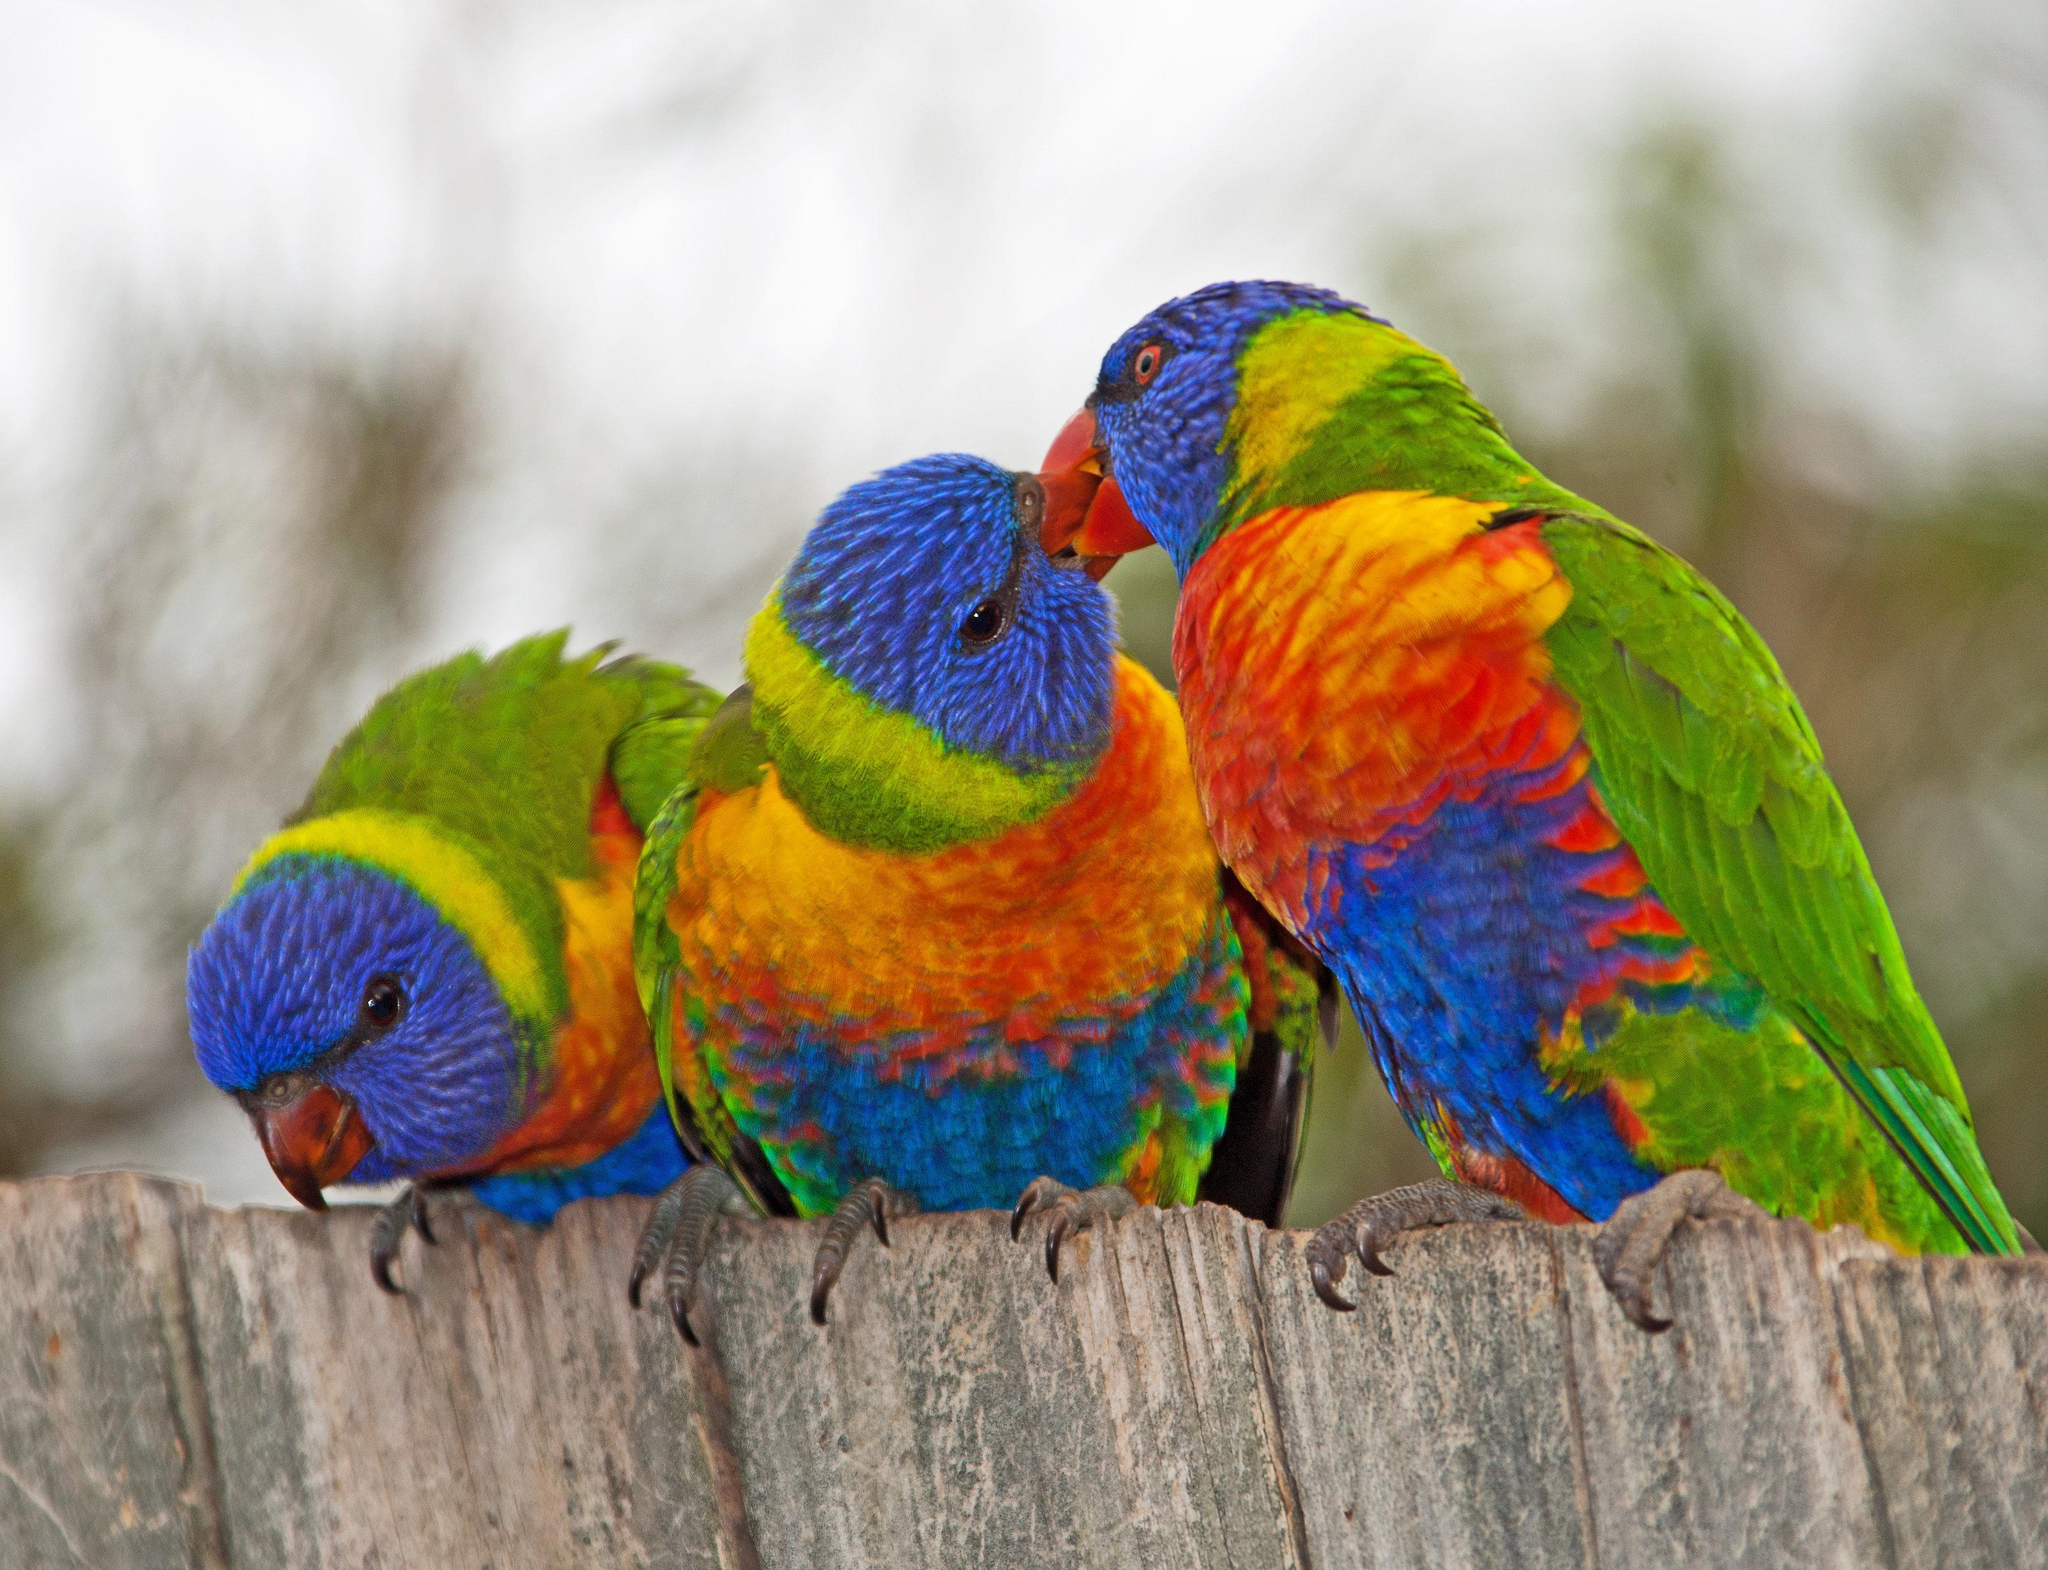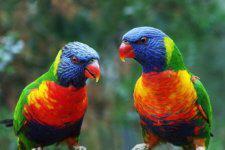The first image is the image on the left, the second image is the image on the right. Evaluate the accuracy of this statement regarding the images: "Two colorful birds are perched on a wooden fence.". Is it true? Answer yes or no. No. The first image is the image on the left, the second image is the image on the right. Analyze the images presented: Is the assertion "Each image depicts exactly two multi-colored parrots." valid? Answer yes or no. No. 